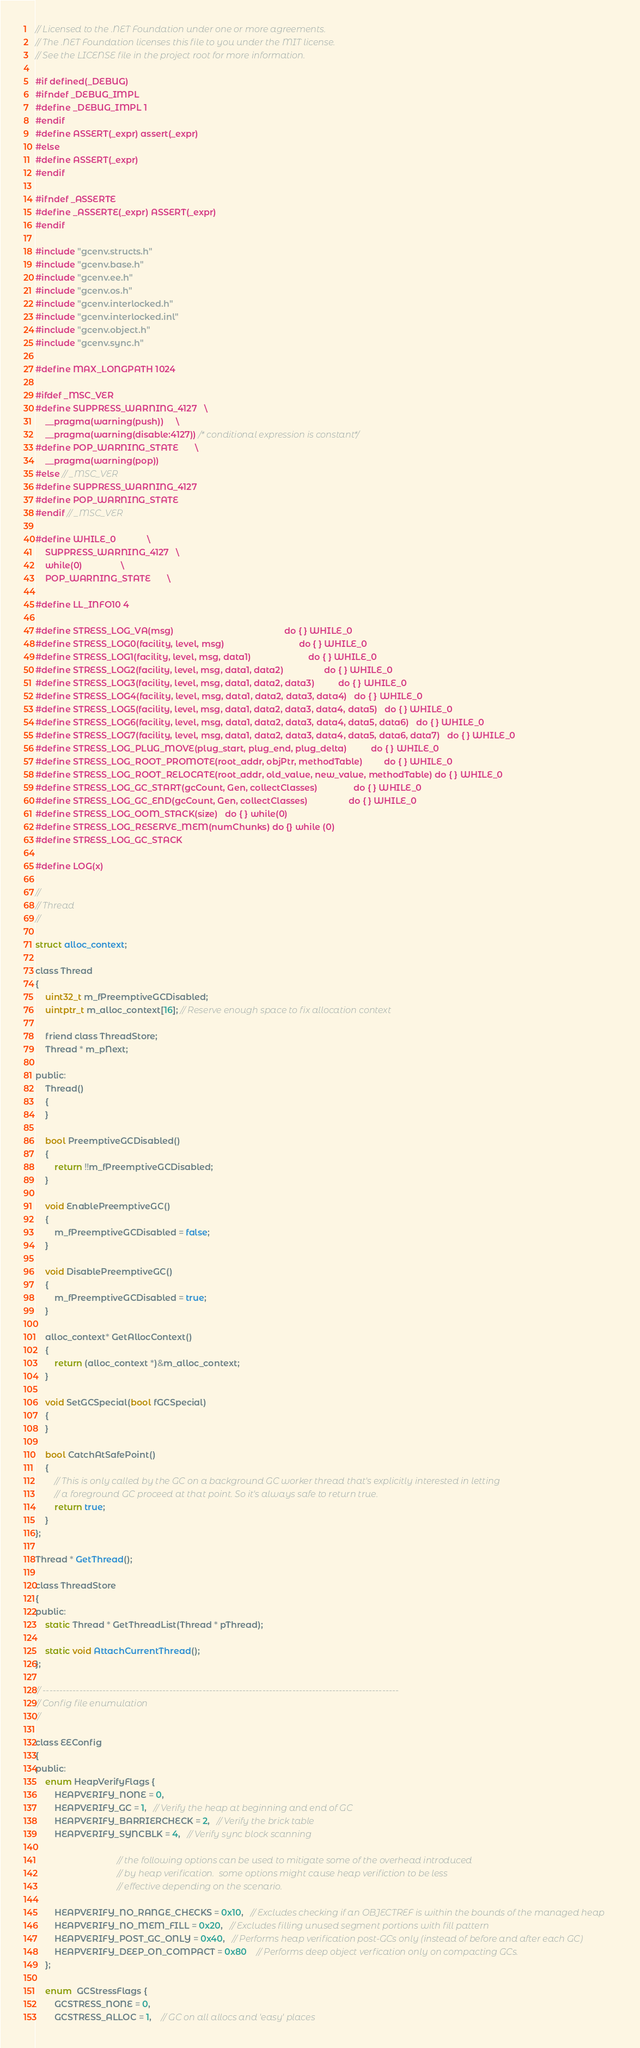Convert code to text. <code><loc_0><loc_0><loc_500><loc_500><_C_>// Licensed to the .NET Foundation under one or more agreements.
// The .NET Foundation licenses this file to you under the MIT license.
// See the LICENSE file in the project root for more information.

#if defined(_DEBUG)
#ifndef _DEBUG_IMPL
#define _DEBUG_IMPL 1
#endif
#define ASSERT(_expr) assert(_expr)
#else
#define ASSERT(_expr)
#endif

#ifndef _ASSERTE
#define _ASSERTE(_expr) ASSERT(_expr)
#endif

#include "gcenv.structs.h"
#include "gcenv.base.h"
#include "gcenv.ee.h"
#include "gcenv.os.h"
#include "gcenv.interlocked.h"
#include "gcenv.interlocked.inl"
#include "gcenv.object.h"
#include "gcenv.sync.h"

#define MAX_LONGPATH 1024

#ifdef _MSC_VER
#define SUPPRESS_WARNING_4127   \
    __pragma(warning(push))     \
    __pragma(warning(disable:4127)) /* conditional expression is constant*/
#define POP_WARNING_STATE       \
    __pragma(warning(pop))
#else // _MSC_VER
#define SUPPRESS_WARNING_4127
#define POP_WARNING_STATE
#endif // _MSC_VER

#define WHILE_0             \
    SUPPRESS_WARNING_4127   \
    while(0)                \
    POP_WARNING_STATE       \

#define LL_INFO10 4

#define STRESS_LOG_VA(msg)                                              do { } WHILE_0
#define STRESS_LOG0(facility, level, msg)                               do { } WHILE_0
#define STRESS_LOG1(facility, level, msg, data1)                        do { } WHILE_0
#define STRESS_LOG2(facility, level, msg, data1, data2)                 do { } WHILE_0
#define STRESS_LOG3(facility, level, msg, data1, data2, data3)          do { } WHILE_0
#define STRESS_LOG4(facility, level, msg, data1, data2, data3, data4)   do { } WHILE_0
#define STRESS_LOG5(facility, level, msg, data1, data2, data3, data4, data5)   do { } WHILE_0
#define STRESS_LOG6(facility, level, msg, data1, data2, data3, data4, data5, data6)   do { } WHILE_0
#define STRESS_LOG7(facility, level, msg, data1, data2, data3, data4, data5, data6, data7)   do { } WHILE_0
#define STRESS_LOG_PLUG_MOVE(plug_start, plug_end, plug_delta)          do { } WHILE_0
#define STRESS_LOG_ROOT_PROMOTE(root_addr, objPtr, methodTable)         do { } WHILE_0
#define STRESS_LOG_ROOT_RELOCATE(root_addr, old_value, new_value, methodTable) do { } WHILE_0
#define STRESS_LOG_GC_START(gcCount, Gen, collectClasses)               do { } WHILE_0
#define STRESS_LOG_GC_END(gcCount, Gen, collectClasses)                 do { } WHILE_0
#define STRESS_LOG_OOM_STACK(size)   do { } while(0)
#define STRESS_LOG_RESERVE_MEM(numChunks) do {} while (0)
#define STRESS_LOG_GC_STACK

#define LOG(x)

//
// Thread
//

struct alloc_context;

class Thread
{
    uint32_t m_fPreemptiveGCDisabled;
    uintptr_t m_alloc_context[16]; // Reserve enough space to fix allocation context

    friend class ThreadStore;
    Thread * m_pNext;

public:
    Thread()
    {
    }

    bool PreemptiveGCDisabled()
    {
        return !!m_fPreemptiveGCDisabled;
    }

    void EnablePreemptiveGC()
    {
        m_fPreemptiveGCDisabled = false;
    }

    void DisablePreemptiveGC()
    {
        m_fPreemptiveGCDisabled = true;
    }

    alloc_context* GetAllocContext()
    {
        return (alloc_context *)&m_alloc_context;
    }

    void SetGCSpecial(bool fGCSpecial)
    {
    }

    bool CatchAtSafePoint()
    {
        // This is only called by the GC on a background GC worker thread that's explicitly interested in letting
        // a foreground GC proceed at that point. So it's always safe to return true.
        return true;
    }
};

Thread * GetThread();

class ThreadStore
{
public:
    static Thread * GetThreadList(Thread * pThread);

    static void AttachCurrentThread();
};

// -----------------------------------------------------------------------------------------------------------
// Config file enumulation
//

class EEConfig
{
public:
    enum HeapVerifyFlags {
        HEAPVERIFY_NONE = 0,
        HEAPVERIFY_GC = 1,   // Verify the heap at beginning and end of GC
        HEAPVERIFY_BARRIERCHECK = 2,   // Verify the brick table
        HEAPVERIFY_SYNCBLK = 4,   // Verify sync block scanning

                                  // the following options can be used to mitigate some of the overhead introduced
                                  // by heap verification.  some options might cause heap verifiction to be less
                                  // effective depending on the scenario.

        HEAPVERIFY_NO_RANGE_CHECKS = 0x10,   // Excludes checking if an OBJECTREF is within the bounds of the managed heap
        HEAPVERIFY_NO_MEM_FILL = 0x20,   // Excludes filling unused segment portions with fill pattern
        HEAPVERIFY_POST_GC_ONLY = 0x40,   // Performs heap verification post-GCs only (instead of before and after each GC)
        HEAPVERIFY_DEEP_ON_COMPACT = 0x80    // Performs deep object verfication only on compacting GCs.
    };

    enum  GCStressFlags {
        GCSTRESS_NONE = 0,
        GCSTRESS_ALLOC = 1,    // GC on all allocs and 'easy' places</code> 